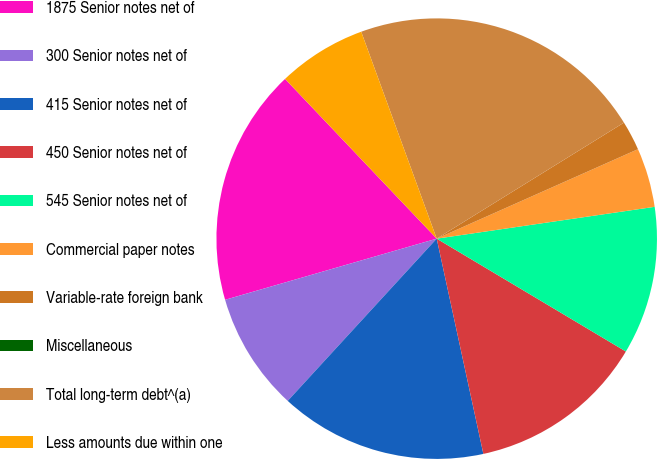Convert chart to OTSL. <chart><loc_0><loc_0><loc_500><loc_500><pie_chart><fcel>1875 Senior notes net of<fcel>300 Senior notes net of<fcel>415 Senior notes net of<fcel>450 Senior notes net of<fcel>545 Senior notes net of<fcel>Commercial paper notes<fcel>Variable-rate foreign bank<fcel>Miscellaneous<fcel>Total long-term debt^(a)<fcel>Less amounts due within one<nl><fcel>17.39%<fcel>8.7%<fcel>15.22%<fcel>13.04%<fcel>10.87%<fcel>4.35%<fcel>2.17%<fcel>0.0%<fcel>21.74%<fcel>6.52%<nl></chart> 